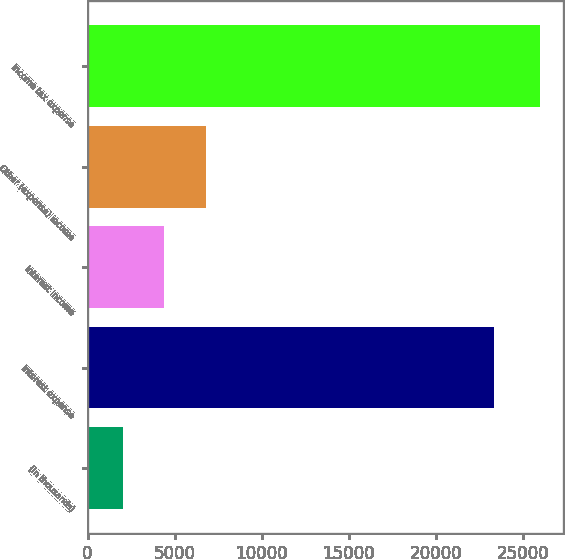Convert chart. <chart><loc_0><loc_0><loc_500><loc_500><bar_chart><fcel>(In thousands)<fcel>Interest expense<fcel>Interest income<fcel>Other (expense) income<fcel>Income tax expense<nl><fcel>2016<fcel>23316<fcel>4412.7<fcel>6809.4<fcel>25983<nl></chart> 